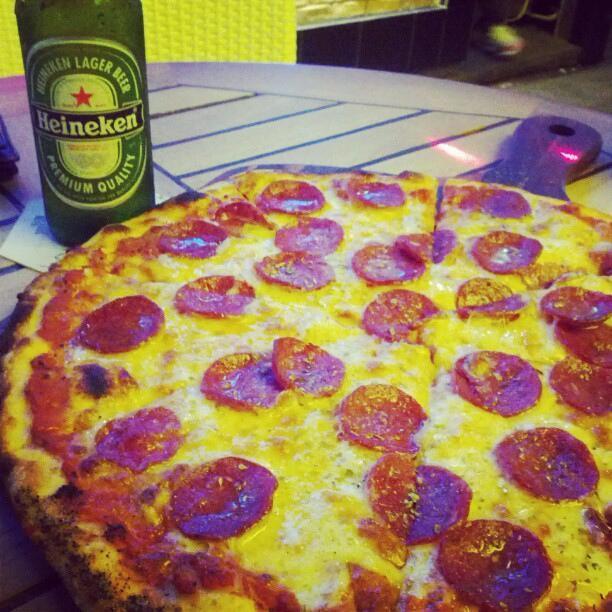Is "The pizza is touching the person." an appropriate description for the image?
Answer yes or no. No. Evaluate: Does the caption "The pizza is with the person." match the image?
Answer yes or no. No. 